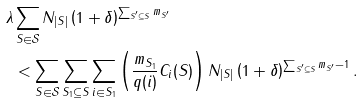Convert formula to latex. <formula><loc_0><loc_0><loc_500><loc_500>\lambda & \sum _ { S \in \mathcal { S } } { N _ { | S | } \left ( 1 + \delta \right ) ^ { \sum _ { S ^ { \prime } \subseteq S } m _ { S ^ { \prime } } } } \\ & < \sum _ { S \in \mathcal { S } } \sum _ { S _ { 1 } \subseteq S } \sum _ { i \in S _ { 1 } } \left ( \frac { m _ { S _ { 1 } } } { q ( i ) } C _ { i } ( S ) \right ) N _ { | S | } \left ( 1 + \delta \right ) ^ { \sum _ { S ^ { \prime } \subseteq S } m _ { S ^ { \prime } } - 1 } .</formula> 